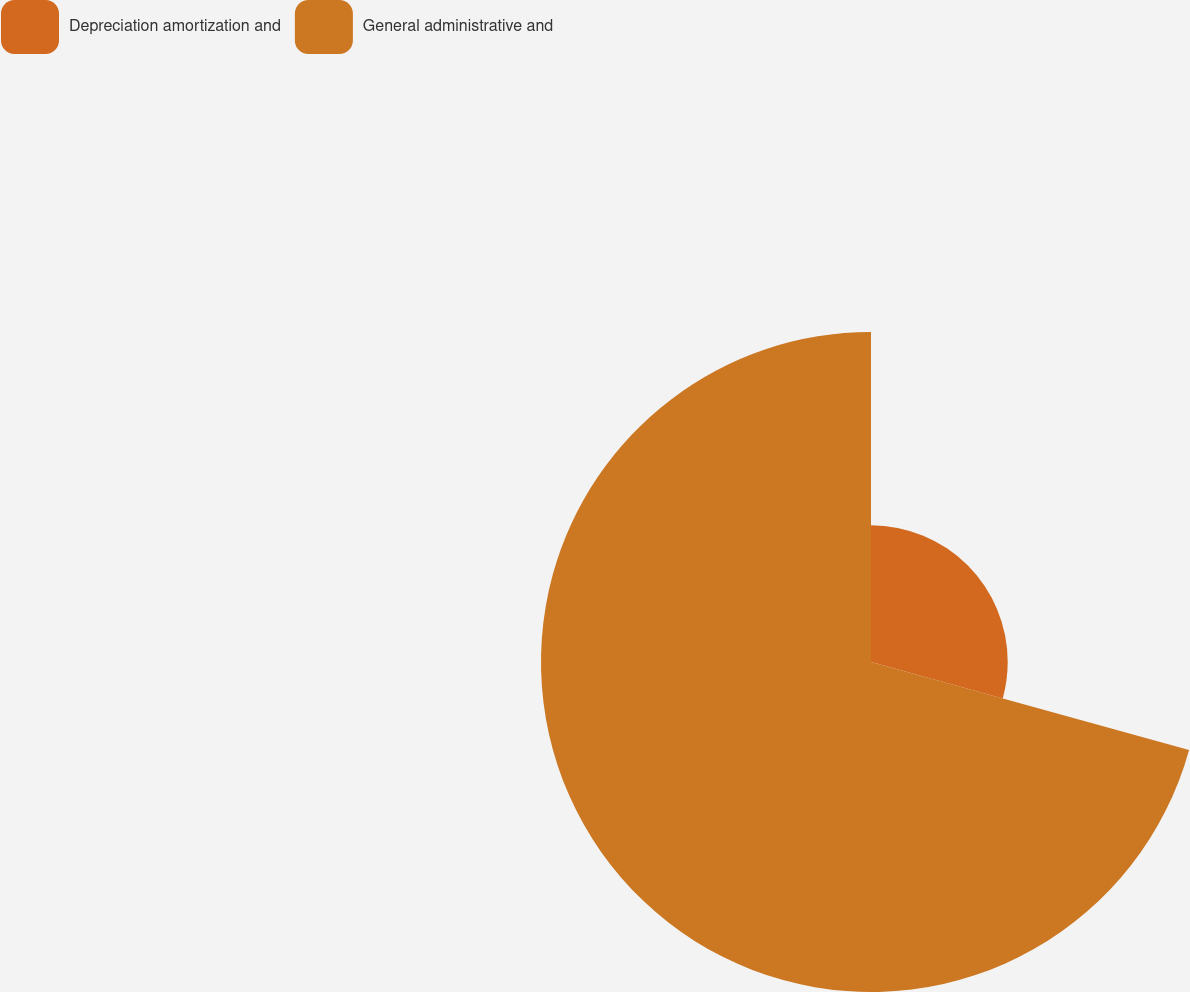<chart> <loc_0><loc_0><loc_500><loc_500><pie_chart><fcel>Depreciation amortization and<fcel>General administrative and<nl><fcel>29.29%<fcel>70.71%<nl></chart> 